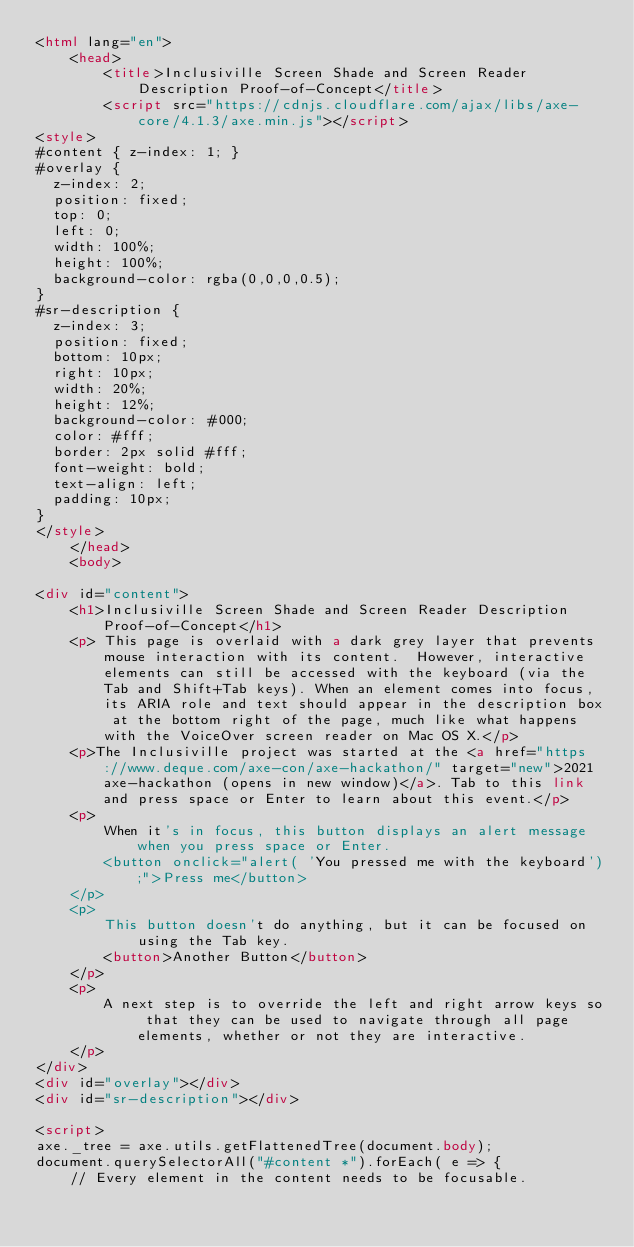<code> <loc_0><loc_0><loc_500><loc_500><_HTML_><html lang="en">
    <head>
        <title>Inclusiville Screen Shade and Screen Reader Description Proof-of-Concept</title>
        <script src="https://cdnjs.cloudflare.com/ajax/libs/axe-core/4.1.3/axe.min.js"></script>
<style>
#content { z-index: 1; }
#overlay {
  z-index: 2;
	position: fixed;
	top: 0;
	left: 0;
	width: 100%;
	height: 100%;
	background-color: rgba(0,0,0,0.5);
}
#sr-description {
  z-index: 3;
  position: fixed;
  bottom: 10px;
  right: 10px;
  width: 20%;
  height: 12%;
  background-color: #000;
  color: #fff;
  border: 2px solid #fff;
  font-weight: bold;
  text-align: left;
  padding: 10px;
}
</style>
    </head>
    <body>

<div id="content">
    <h1>Inclusiville Screen Shade and Screen Reader Description Proof-of-Concept</h1>
    <p> This page is overlaid with a dark grey layer that prevents mouse interaction with its content.  However, interactive elements can still be accessed with the keyboard (via the Tab and Shift+Tab keys). When an element comes into focus, its ARIA role and text should appear in the description box at the bottom right of the page, much like what happens with the VoiceOver screen reader on Mac OS X.</p>
    <p>The Inclusiville project was started at the <a href="https://www.deque.com/axe-con/axe-hackathon/" target="new">2021 axe-hackathon (opens in new window)</a>. Tab to this link and press space or Enter to learn about this event.</p>
    <p>
        When it's in focus, this button displays an alert message when you press space or Enter.
        <button onclick="alert( 'You pressed me with the keyboard');">Press me</button>
    </p>
    <p>
        This button doesn't do anything, but it can be focused on using the Tab key.
        <button>Another Button</button>
    </p>
    <p>
        A next step is to override the left and right arrow keys so that they can be used to navigate through all page elements, whether or not they are interactive.
    </p>
</div>
<div id="overlay"></div>
<div id="sr-description"></div>

<script>
axe._tree = axe.utils.getFlattenedTree(document.body);
document.querySelectorAll("#content *").forEach( e => {
    // Every element in the content needs to be focusable.</code> 